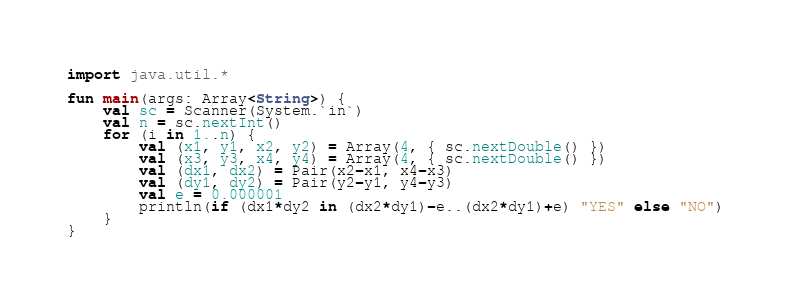<code> <loc_0><loc_0><loc_500><loc_500><_Kotlin_>import java.util.*

fun main(args: Array<String>) {
    val sc = Scanner(System.`in`)
    val n = sc.nextInt()
    for (i in 1..n) {
        val (x1, y1, x2, y2) = Array(4, { sc.nextDouble() })
        val (x3, y3, x4, y4) = Array(4, { sc.nextDouble() })
        val (dx1, dx2) = Pair(x2-x1, x4-x3)
        val (dy1, dy2) = Pair(y2-y1, y4-y3)
        val e = 0.000001
        println(if (dx1*dy2 in (dx2*dy1)-e..(dx2*dy1)+e) "YES" else "NO")
    }
}
</code> 